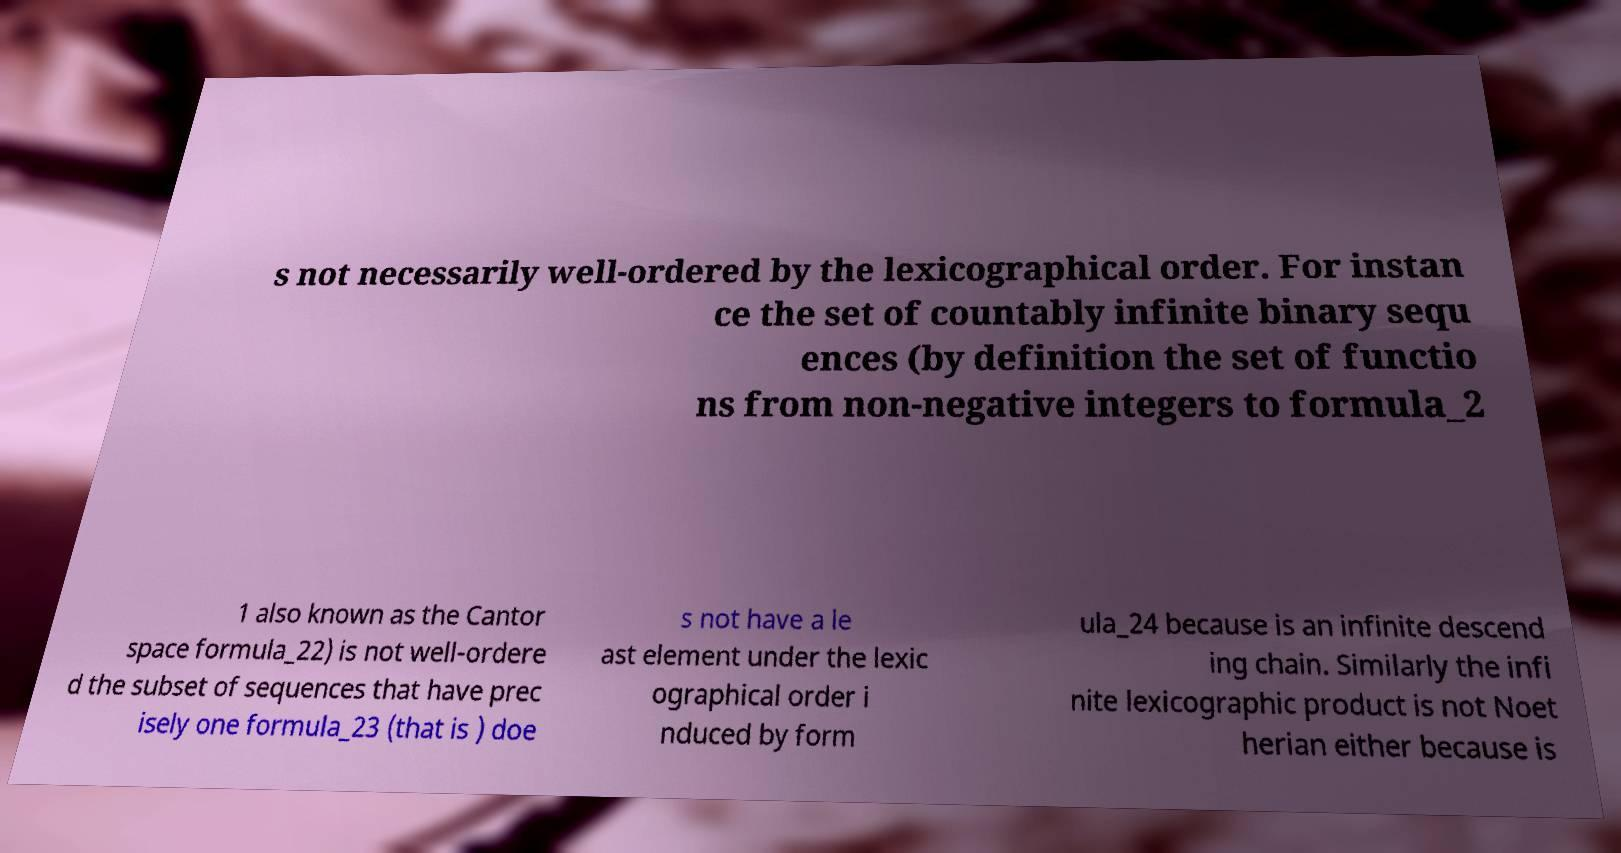Can you read and provide the text displayed in the image?This photo seems to have some interesting text. Can you extract and type it out for me? s not necessarily well-ordered by the lexicographical order. For instan ce the set of countably infinite binary sequ ences (by definition the set of functio ns from non-negative integers to formula_2 1 also known as the Cantor space formula_22) is not well-ordere d the subset of sequences that have prec isely one formula_23 (that is ) doe s not have a le ast element under the lexic ographical order i nduced by form ula_24 because is an infinite descend ing chain. Similarly the infi nite lexicographic product is not Noet herian either because is 